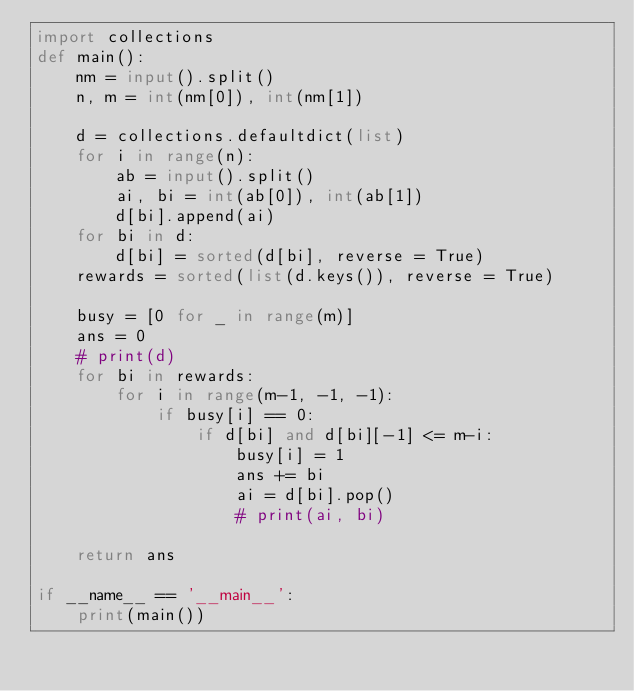<code> <loc_0><loc_0><loc_500><loc_500><_Python_>import collections
def main():
    nm = input().split()
    n, m = int(nm[0]), int(nm[1])

    d = collections.defaultdict(list)
    for i in range(n):
        ab = input().split()
        ai, bi = int(ab[0]), int(ab[1])
        d[bi].append(ai)
    for bi in d:
        d[bi] = sorted(d[bi], reverse = True)
    rewards = sorted(list(d.keys()), reverse = True)

    busy = [0 for _ in range(m)]
    ans = 0
    # print(d)
    for bi in rewards:
        for i in range(m-1, -1, -1):
            if busy[i] == 0:
                if d[bi] and d[bi][-1] <= m-i:
                    busy[i] = 1
                    ans += bi
                    ai = d[bi].pop()
                    # print(ai, bi)

    return ans

if __name__ == '__main__':
    print(main())</code> 